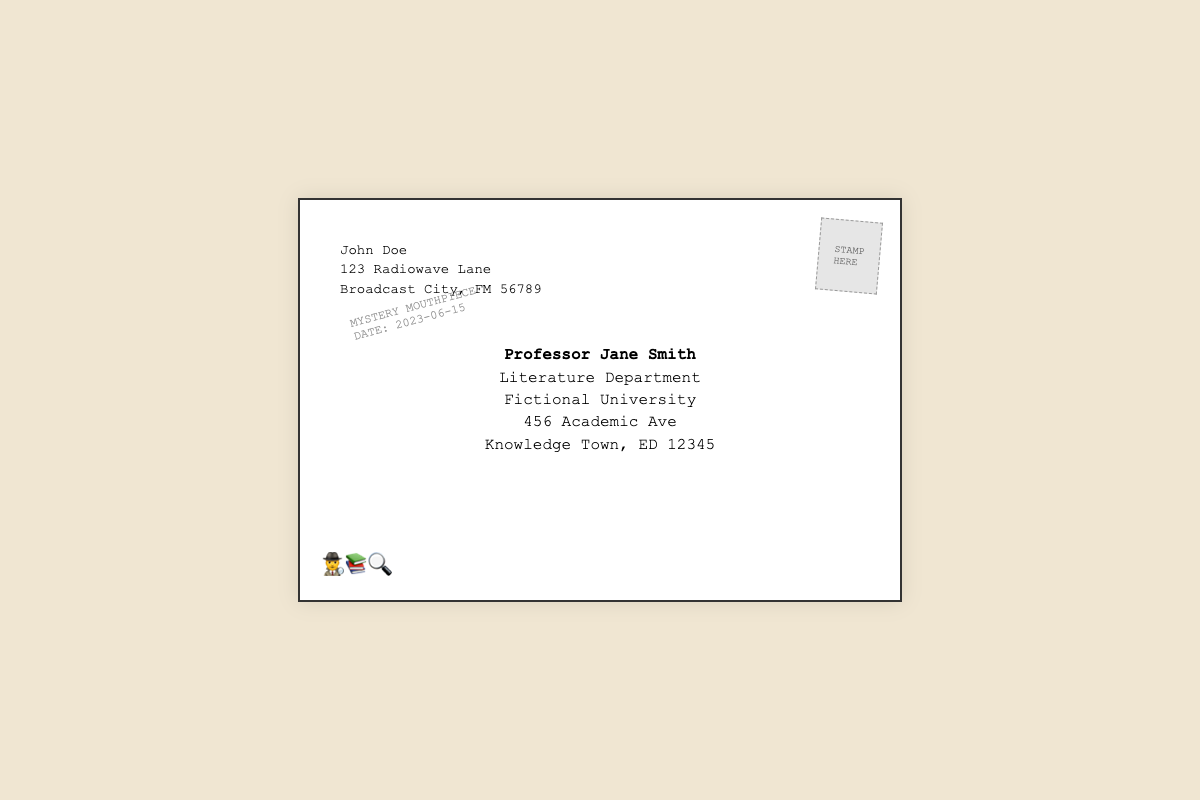What is the name of the sender? The sender's name is clearly stated at the top left of the envelope.
Answer: John Doe What is the recipient's title? The title of the recipient is mentioned directly below their name in the center of the envelope.
Answer: Professor What is the postal code of the sender's address? The zip code for the sender's address is located at the end of the sender's address section.
Answer: 56789 What date is noted on the postmark? The date on the postmark indicates when the envelope was noted to be sent, found in the bottom left area of the envelope.
Answer: 2023-06-15 What icon is used to represent mystery? The icon present at the bottom left corner of the envelope symbolizes mystery-related themes.
Answer: 🕵️‍♂️ Which university is the recipient associated with? The name of the university related to the recipient is clearly stated just below the recipient's title.
Answer: Fictional University What is the background color of the envelope? The background color is described in the style section of the document and can be observed visually.
Answer: #f0e6d2 What type of note is featured in this document? The type of note this document represents can be discerned from its overall layout and design.
Answer: Thank-you note 